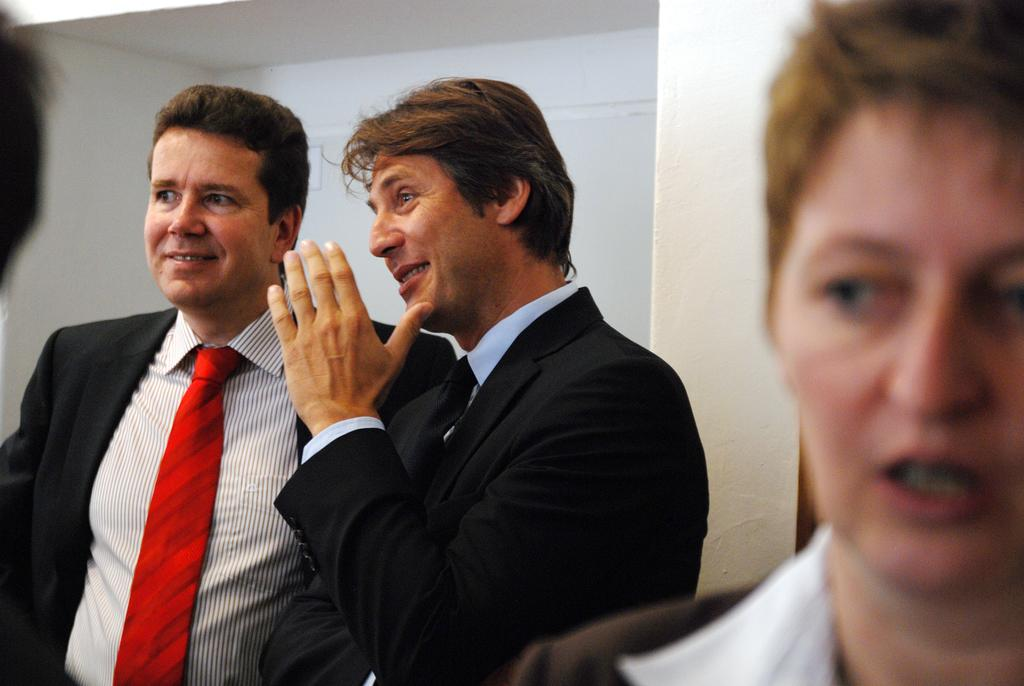How many people are present in the image? There are two men standing in the image. What are the men doing in the image? The men are smiling and speaking to each other. What is visible behind the men? There is a wall behind the men. Are there any other people in the image? Yes, there is another person to the right of the men. What type of furniture can be seen in the harbor in the image? There is no furniture or harbor present in the image. 